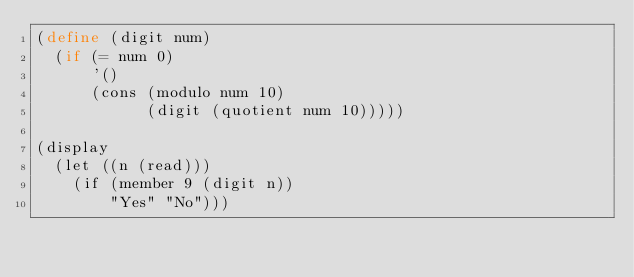<code> <loc_0><loc_0><loc_500><loc_500><_Scheme_>(define (digit num)
  (if (= num 0)
      '()
      (cons (modulo num 10)
            (digit (quotient num 10)))))

(display
  (let ((n (read)))
    (if (member 9 (digit n))
        "Yes" "No")))
</code> 